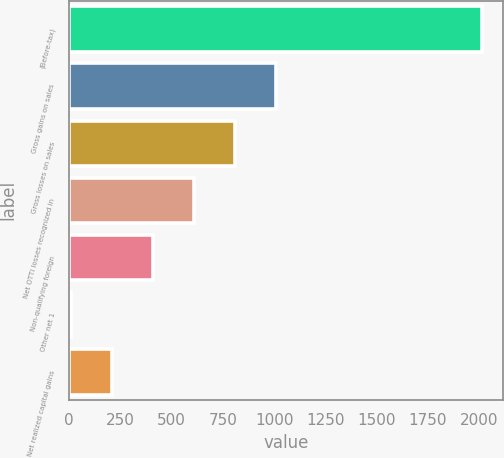<chart> <loc_0><loc_0><loc_500><loc_500><bar_chart><fcel>(Before-tax)<fcel>Gross gains on sales<fcel>Gross losses on sales<fcel>Net OTTI losses recognized in<fcel>Non-qualifying foreign<fcel>Other net 1<fcel>Net realized capital gains<nl><fcel>2015<fcel>1011.5<fcel>810.8<fcel>610.1<fcel>409.4<fcel>8<fcel>208.7<nl></chart> 